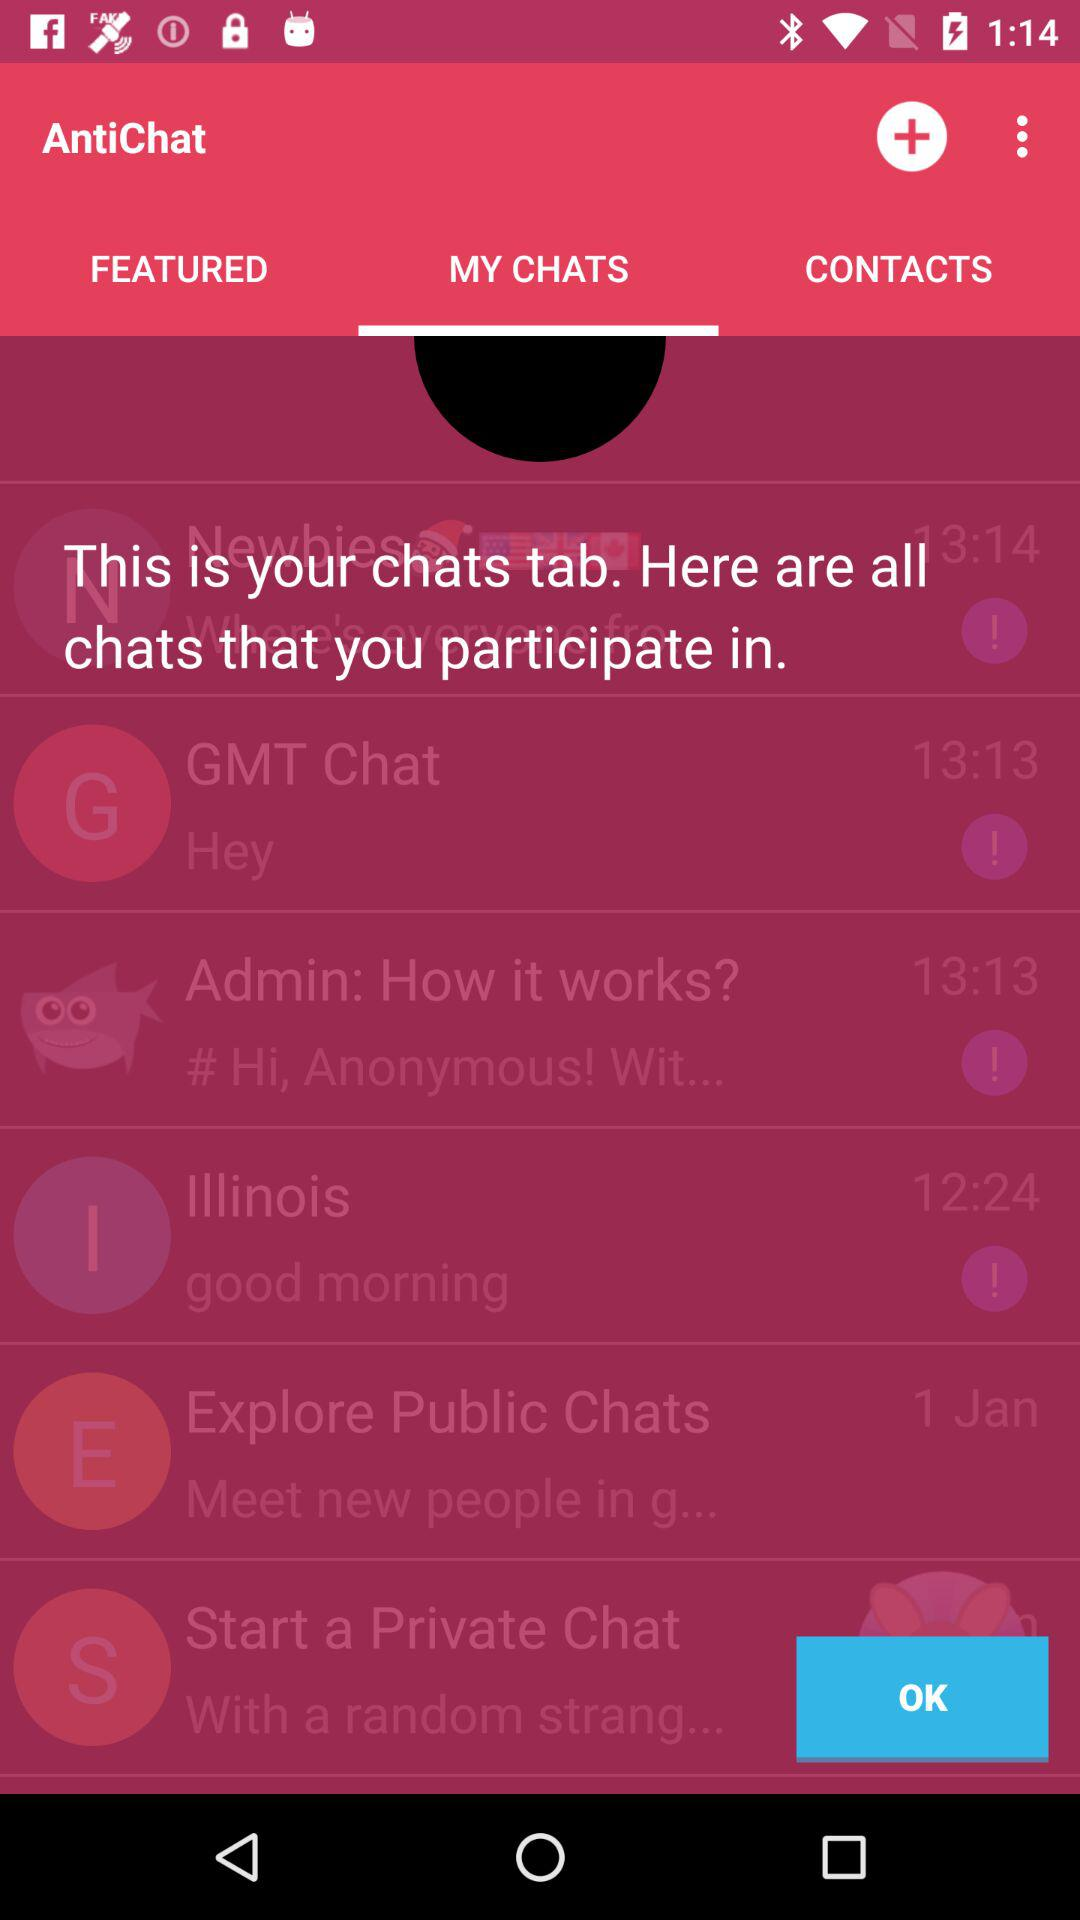What are the available chats? The available chats are "Where's everyone fro", "Hey", "# Hi, Anonymous! wit...", "good morning", "Meet new people in g..." and "With a random strang...". 